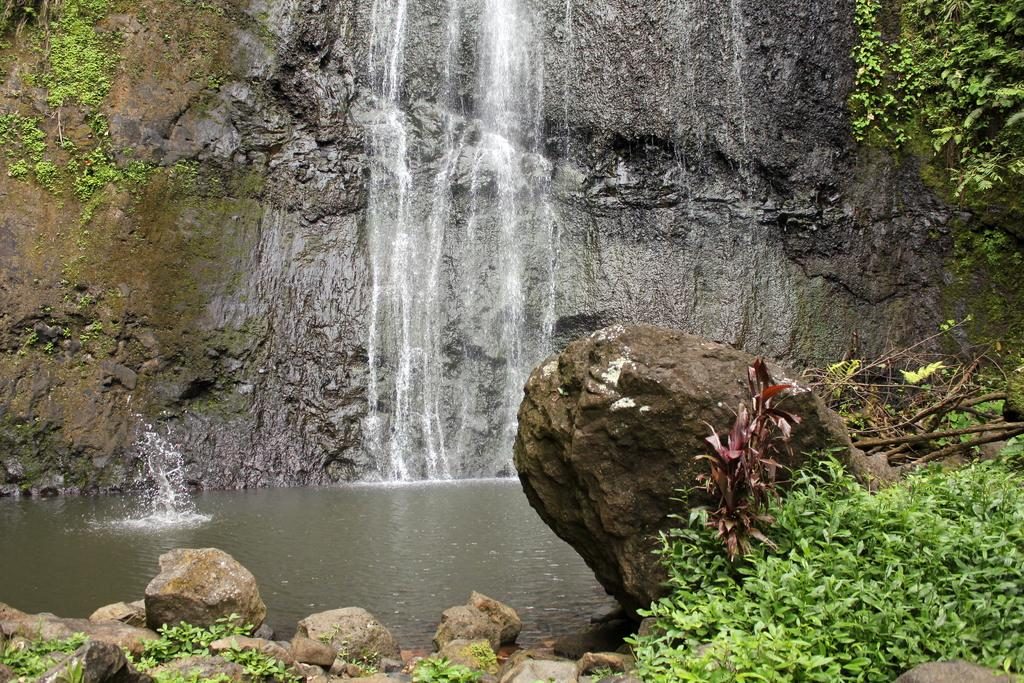What natural feature is the main subject of the image? There is a waterfall in the image. What is located in the center of the image? There is water in the center of the image. What type of vegetation can be seen at the bottom of the image? There are plants at the bottom of the image. What else is present at the bottom of the image? There are stones at the bottom of the image. What type of discussion is taking place in the image? There is no discussion taking place in the image; it features a waterfall, water, plants, and stones. Can you see a church in the image? There is no church present in the image. 